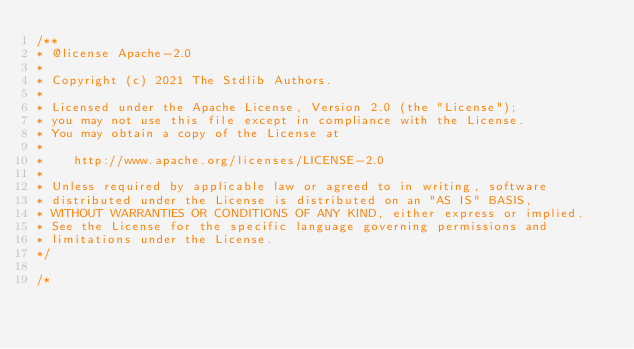Convert code to text. <code><loc_0><loc_0><loc_500><loc_500><_C_>/**
* @license Apache-2.0
*
* Copyright (c) 2021 The Stdlib Authors.
*
* Licensed under the Apache License, Version 2.0 (the "License");
* you may not use this file except in compliance with the License.
* You may obtain a copy of the License at
*
*    http://www.apache.org/licenses/LICENSE-2.0
*
* Unless required by applicable law or agreed to in writing, software
* distributed under the License is distributed on an "AS IS" BASIS,
* WITHOUT WARRANTIES OR CONDITIONS OF ANY KIND, either express or implied.
* See the License for the specific language governing permissions and
* limitations under the License.
*/

/*</code> 